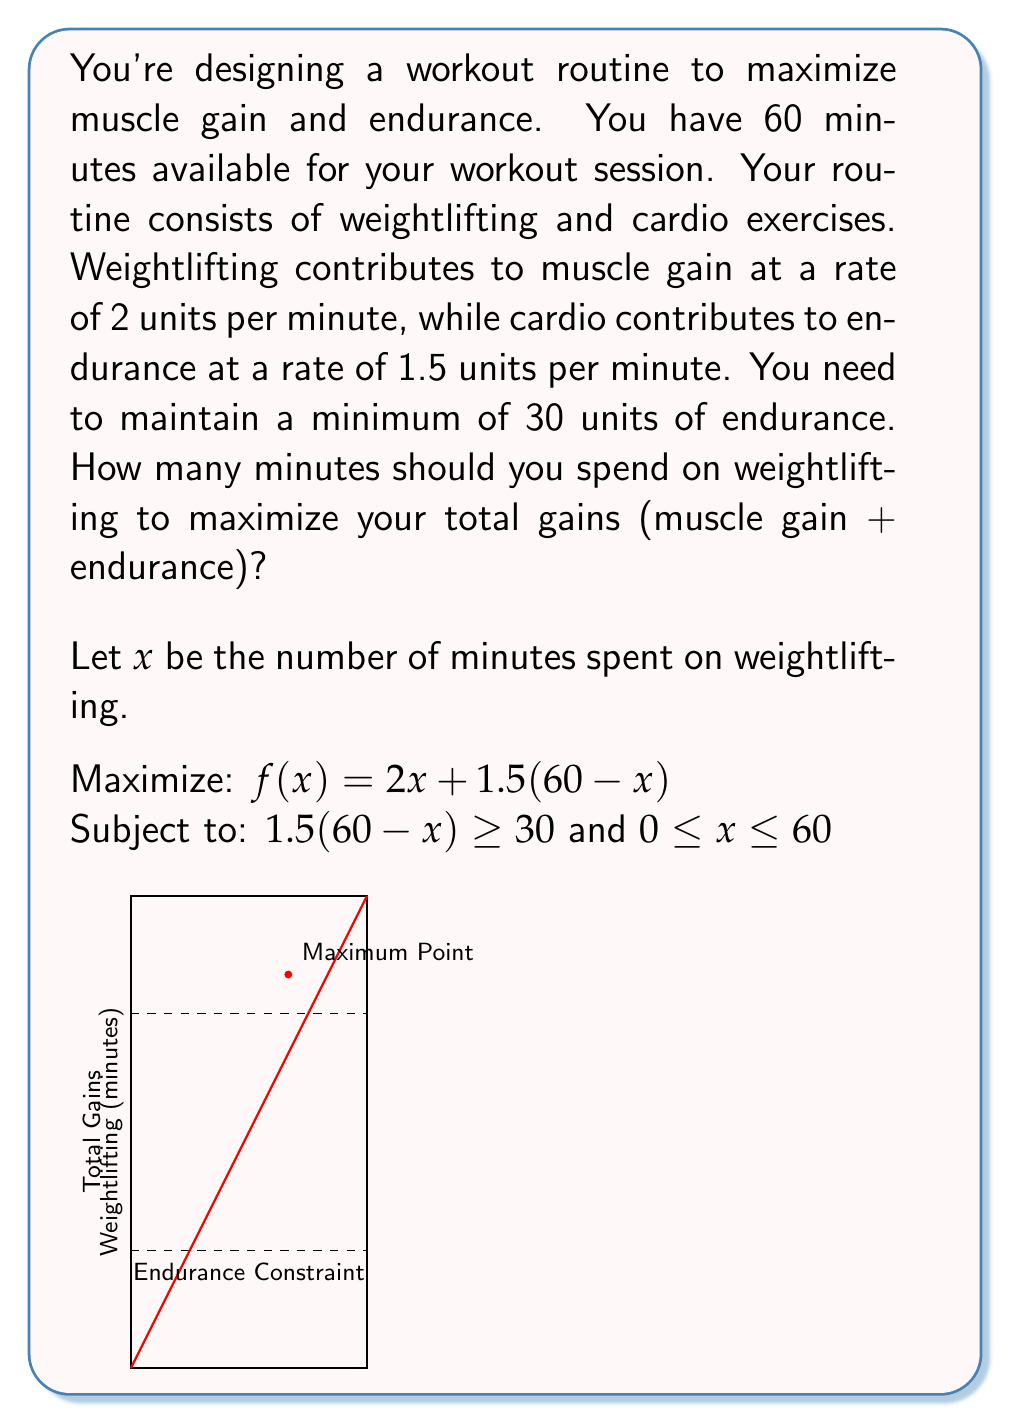What is the answer to this math problem? Let's solve this step-by-step:

1) First, let's interpret the constraints:
   $1.5(60-x) \geq 30$ ensures minimum endurance
   $0 \leq x \leq 60$ ensures time spent is non-negative and doesn't exceed total time

2) From the endurance constraint:
   $1.5(60-x) \geq 30$
   $90 - 1.5x \geq 30$
   $-1.5x \geq -60$
   $x \leq 40$

3) Our objective function is:
   $f(x) = 2x + 1.5(60-x) = 2x + 90 - 1.5x = 0.5x + 90$

4) This is a linear function, so the maximum will occur at one of the endpoints of our feasible region.

5) Our feasible region is $0 \leq x \leq 40$ (combining steps 1 and 2)

6) Let's evaluate $f(x)$ at these points:
   At $x = 0$: $f(0) = 90$
   At $x = 40$: $f(40) = 0.5(40) + 90 = 110$

7) The maximum occurs at $x = 40$

Therefore, you should spend 40 minutes on weightlifting to maximize your total gains.
Answer: 40 minutes 